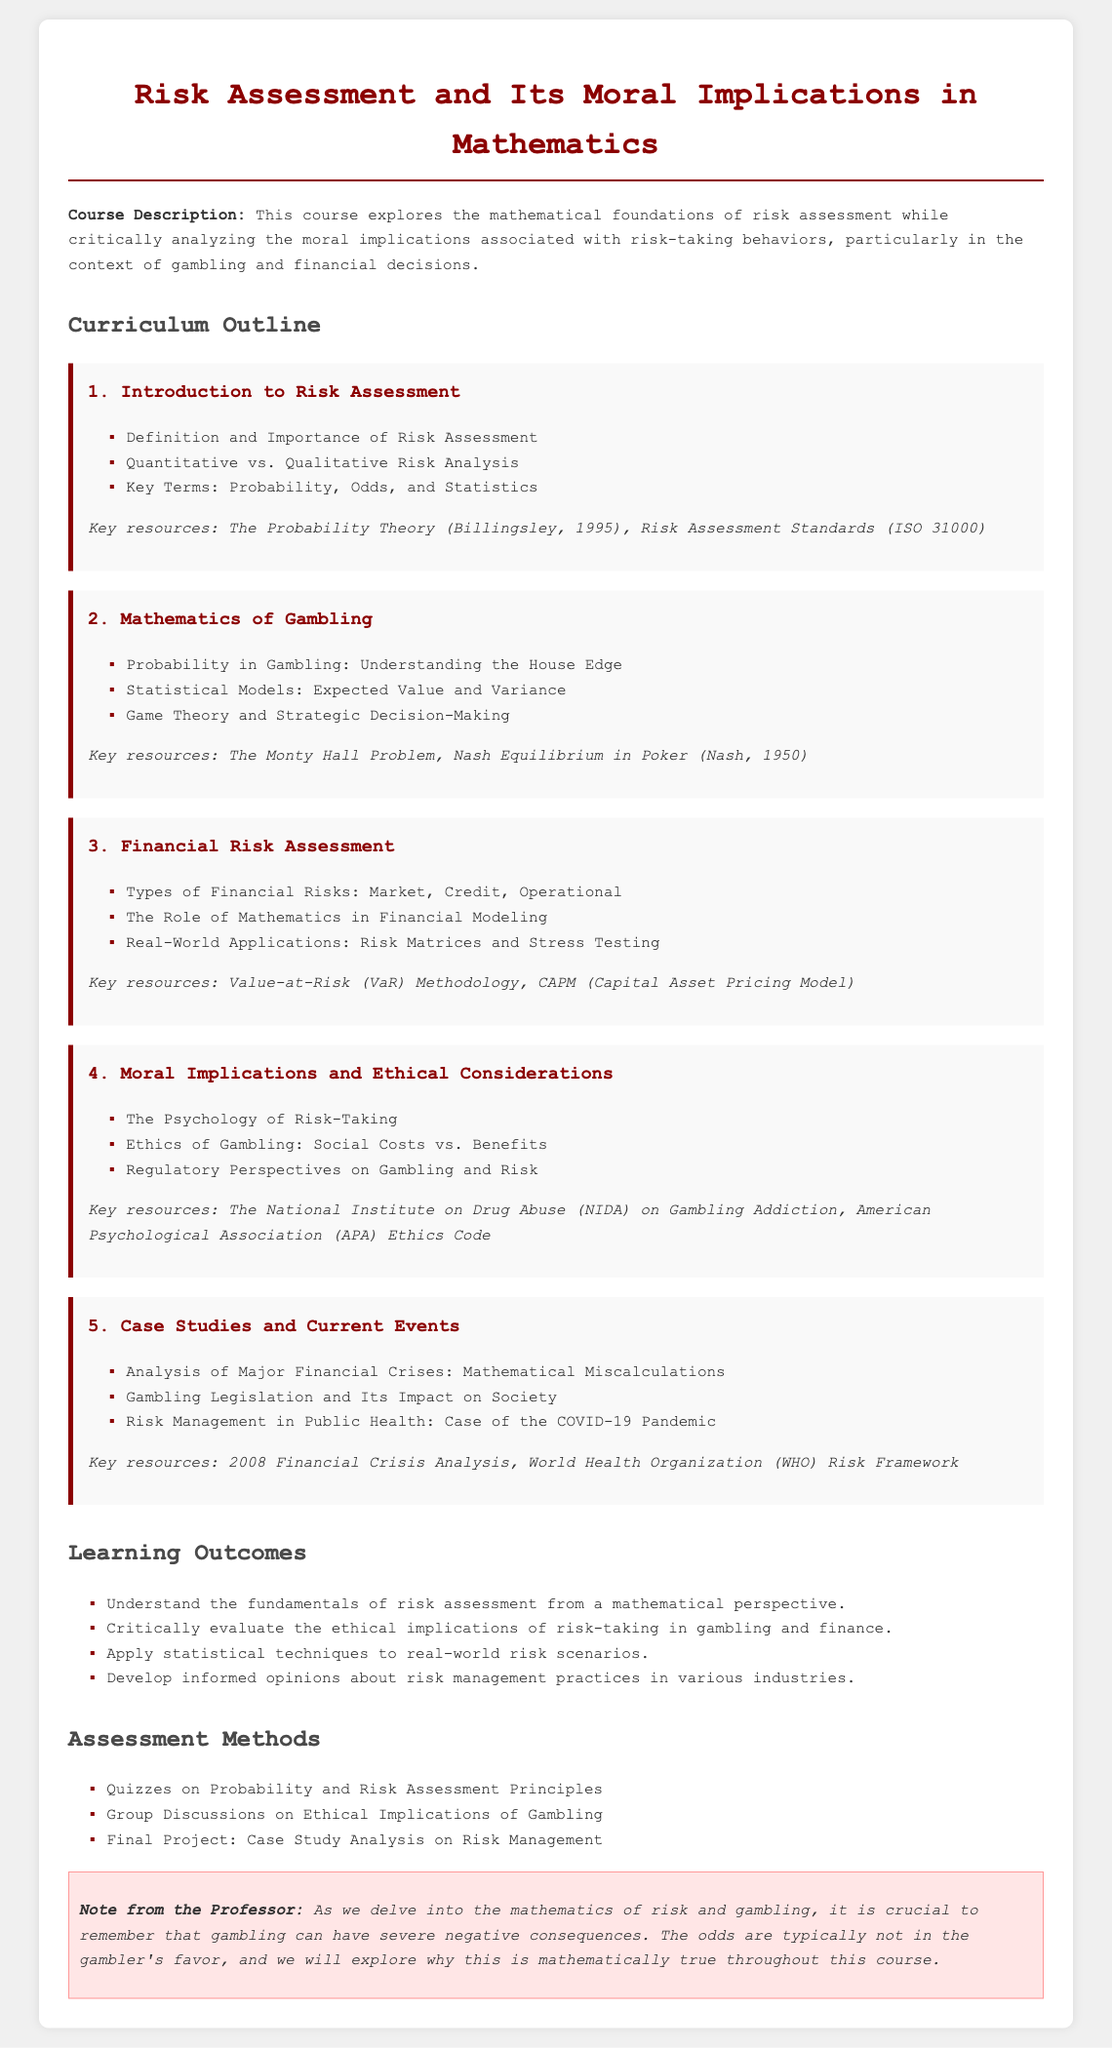What is the title of the course? The title is listed at the top of the document under the main heading, which summarizes the course's focus.
Answer: Risk Assessment and Its Moral Implications in Mathematics What is covered in Module 2? Module 2 specifically addresses the mathematics behind gambling, detailing its components and theories.
Answer: Mathematics of Gambling What are the learning outcomes? The section on learning outcomes enumerates what students are expected to achieve upon completing the course.
Answer: Understanding the fundamentals of risk assessment from a mathematical perspective What type of assessment involves group discussions? The assessment methods section outlines the various formats of evaluation that students will undergo.
Answer: Group Discussions on Ethical Implications of Gambling What key resource is mentioned for Module 4? Each module lists important literature to support student learning, particularly in the area of ethics related to gambling.
Answer: The National Institute on Drug Abuse (NIDA) on Gambling Addiction How many modules are included in the curriculum? The curriculum outline contains a specific number of modules, each detailing a unique aspect of the course.
Answer: Five What does the warning at the end emphasize? The warning section from the professor aims to remind students of the severe consequences associated with gambling practices.
Answer: Gambling can have severe negative consequences What is the focus of the third module? Each module focuses on a different area of risk assessment, with Module 3 centering on financial aspects and risks.
Answer: Financial Risk Assessment What statistical models are discussed in Module 2? Module 2 mentions specific statistical models that are crucial in understanding gambling mathematics.
Answer: Expected Value and Variance 